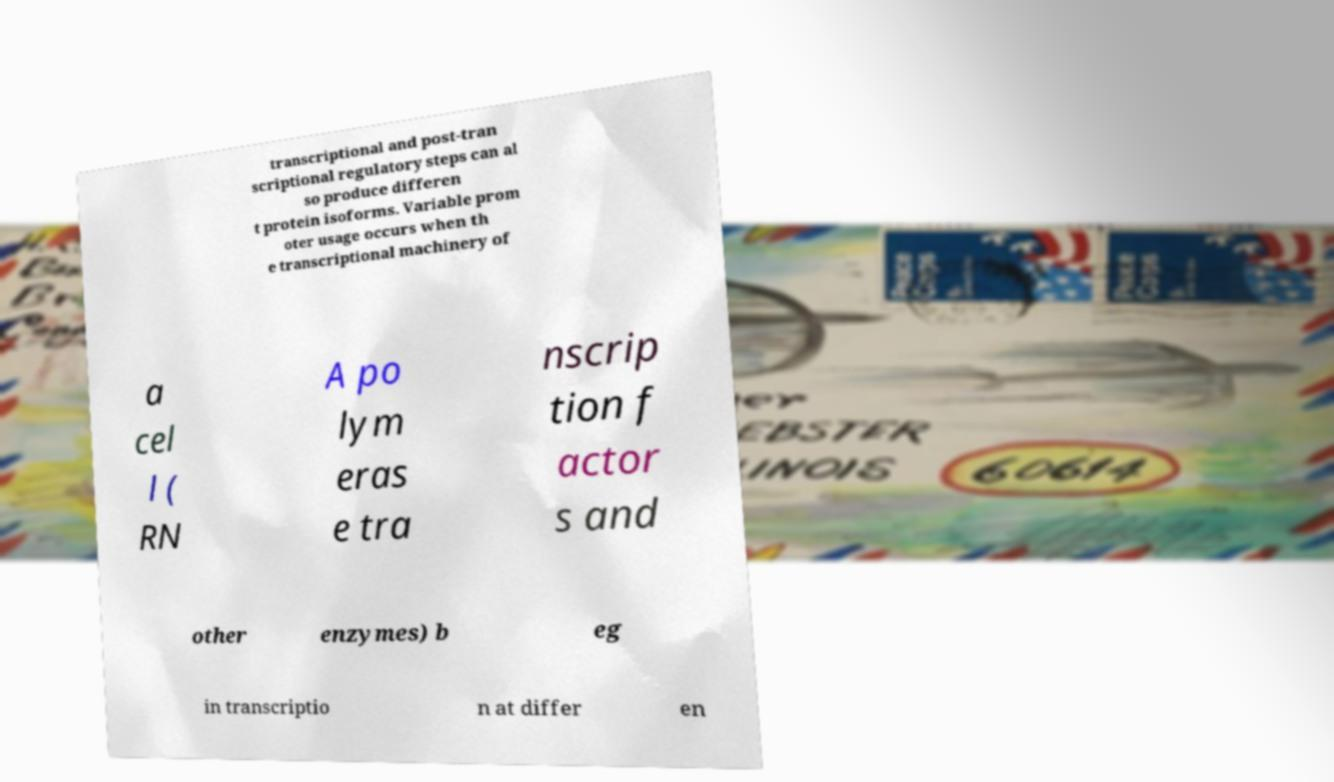Could you extract and type out the text from this image? transcriptional and post-tran scriptional regulatory steps can al so produce differen t protein isoforms. Variable prom oter usage occurs when th e transcriptional machinery of a cel l ( RN A po lym eras e tra nscrip tion f actor s and other enzymes) b eg in transcriptio n at differ en 